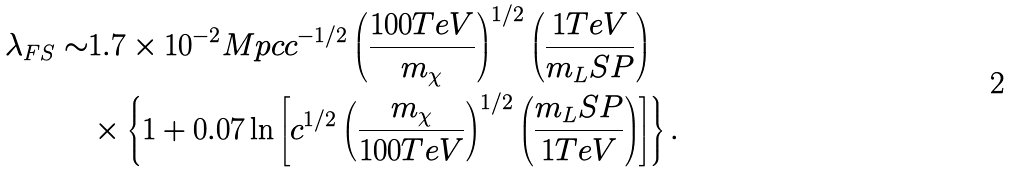<formula> <loc_0><loc_0><loc_500><loc_500>\lambda _ { F S } \sim & 1 . 7 \times 1 0 ^ { - 2 } M p c c ^ { - 1 / 2 } \left ( \frac { 1 0 0 T e V } { m _ { \chi } } \right ) ^ { 1 / 2 } \left ( \frac { 1 T e V } { m _ { L } S P } \right ) \\ & \times \left \{ 1 + 0 . 0 7 \ln \left [ c ^ { 1 / 2 } \left ( \frac { m _ { \chi } } { 1 0 0 T e V } \right ) ^ { 1 / 2 } \left ( \frac { m _ { L } S P } { 1 T e V } \right ) \right ] \right \} .</formula> 